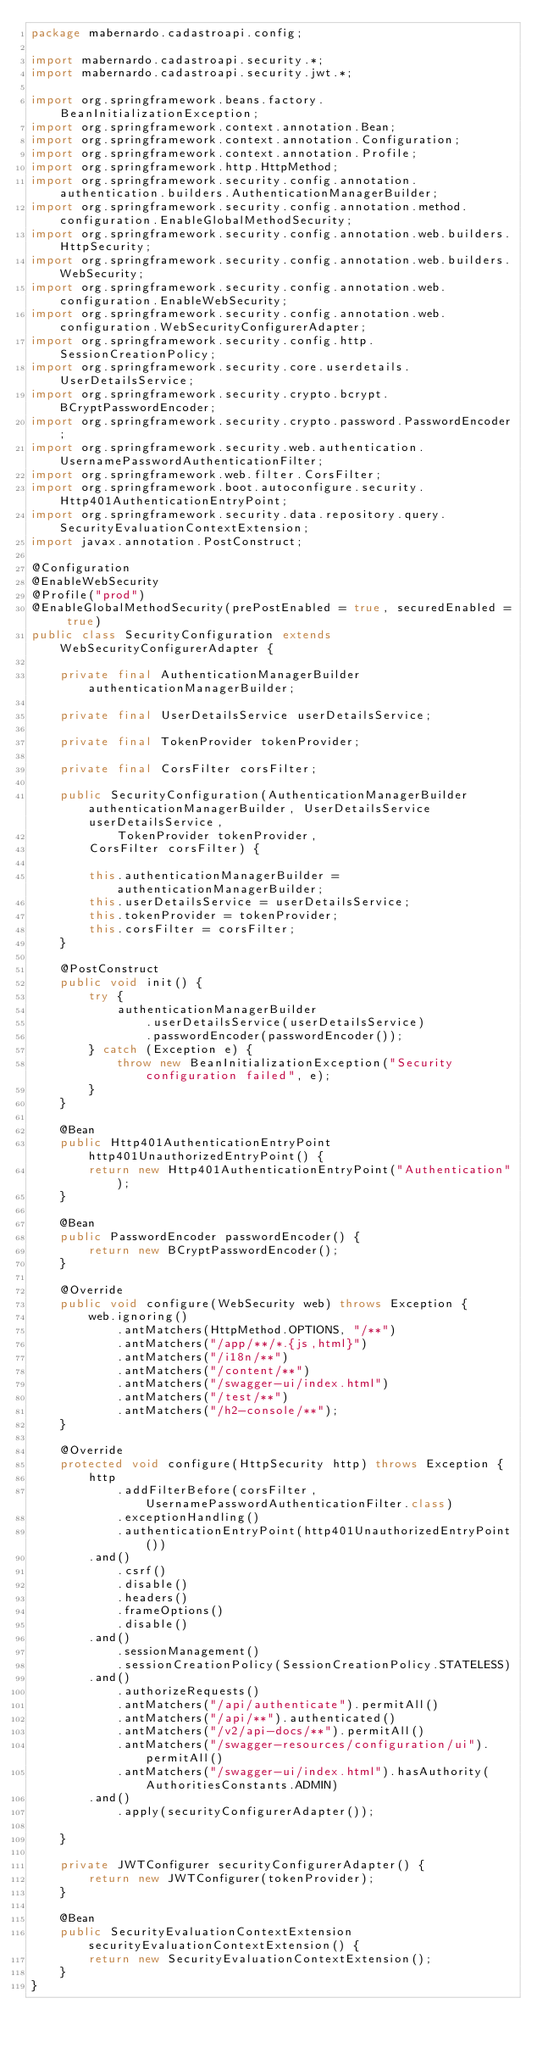<code> <loc_0><loc_0><loc_500><loc_500><_Java_>package mabernardo.cadastroapi.config;

import mabernardo.cadastroapi.security.*;
import mabernardo.cadastroapi.security.jwt.*;

import org.springframework.beans.factory.BeanInitializationException;
import org.springframework.context.annotation.Bean;
import org.springframework.context.annotation.Configuration;
import org.springframework.context.annotation.Profile;
import org.springframework.http.HttpMethod;
import org.springframework.security.config.annotation.authentication.builders.AuthenticationManagerBuilder;
import org.springframework.security.config.annotation.method.configuration.EnableGlobalMethodSecurity;
import org.springframework.security.config.annotation.web.builders.HttpSecurity;
import org.springframework.security.config.annotation.web.builders.WebSecurity;
import org.springframework.security.config.annotation.web.configuration.EnableWebSecurity;
import org.springframework.security.config.annotation.web.configuration.WebSecurityConfigurerAdapter;
import org.springframework.security.config.http.SessionCreationPolicy;
import org.springframework.security.core.userdetails.UserDetailsService;
import org.springframework.security.crypto.bcrypt.BCryptPasswordEncoder;
import org.springframework.security.crypto.password.PasswordEncoder;
import org.springframework.security.web.authentication.UsernamePasswordAuthenticationFilter;
import org.springframework.web.filter.CorsFilter;
import org.springframework.boot.autoconfigure.security.Http401AuthenticationEntryPoint;
import org.springframework.security.data.repository.query.SecurityEvaluationContextExtension;
import javax.annotation.PostConstruct;

@Configuration
@EnableWebSecurity
@Profile("prod")
@EnableGlobalMethodSecurity(prePostEnabled = true, securedEnabled = true)
public class SecurityConfiguration extends WebSecurityConfigurerAdapter {

    private final AuthenticationManagerBuilder authenticationManagerBuilder;

    private final UserDetailsService userDetailsService;

    private final TokenProvider tokenProvider;

    private final CorsFilter corsFilter;

    public SecurityConfiguration(AuthenticationManagerBuilder authenticationManagerBuilder, UserDetailsService userDetailsService,
            TokenProvider tokenProvider,
        CorsFilter corsFilter) {

        this.authenticationManagerBuilder = authenticationManagerBuilder;
        this.userDetailsService = userDetailsService;
        this.tokenProvider = tokenProvider;
        this.corsFilter = corsFilter;
    }

    @PostConstruct
    public void init() {
        try {
            authenticationManagerBuilder
                .userDetailsService(userDetailsService)
                .passwordEncoder(passwordEncoder());
        } catch (Exception e) {
            throw new BeanInitializationException("Security configuration failed", e);
        }
    }

    @Bean
    public Http401AuthenticationEntryPoint http401UnauthorizedEntryPoint() {
        return new Http401AuthenticationEntryPoint("Authentication");
    }

    @Bean
    public PasswordEncoder passwordEncoder() {
        return new BCryptPasswordEncoder();
    }

    @Override
    public void configure(WebSecurity web) throws Exception {
        web.ignoring()
            .antMatchers(HttpMethod.OPTIONS, "/**")
            .antMatchers("/app/**/*.{js,html}")
            .antMatchers("/i18n/**")
            .antMatchers("/content/**")
            .antMatchers("/swagger-ui/index.html")
            .antMatchers("/test/**")
            .antMatchers("/h2-console/**");
    }

    @Override
    protected void configure(HttpSecurity http) throws Exception {
        http
            .addFilterBefore(corsFilter, UsernamePasswordAuthenticationFilter.class)
            .exceptionHandling()
            .authenticationEntryPoint(http401UnauthorizedEntryPoint())
        .and()
            .csrf()
            .disable()
            .headers()
            .frameOptions()
            .disable()
        .and()
            .sessionManagement()
            .sessionCreationPolicy(SessionCreationPolicy.STATELESS)
        .and()
            .authorizeRequests()
            .antMatchers("/api/authenticate").permitAll()
            .antMatchers("/api/**").authenticated()
            .antMatchers("/v2/api-docs/**").permitAll()
            .antMatchers("/swagger-resources/configuration/ui").permitAll()
            .antMatchers("/swagger-ui/index.html").hasAuthority(AuthoritiesConstants.ADMIN)
        .and()
            .apply(securityConfigurerAdapter());

    }

    private JWTConfigurer securityConfigurerAdapter() {
        return new JWTConfigurer(tokenProvider);
    }

    @Bean
    public SecurityEvaluationContextExtension securityEvaluationContextExtension() {
        return new SecurityEvaluationContextExtension();
    }
}
</code> 